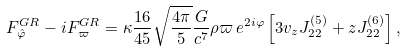<formula> <loc_0><loc_0><loc_500><loc_500>F ^ { G R } _ { \hat { \varphi } } - i F ^ { G R } _ { \varpi } = \kappa \frac { 1 6 } { 4 5 } \sqrt { \frac { 4 \pi } { 5 } } \frac { G } { c ^ { 7 } } \rho \varpi \, e ^ { 2 i \varphi } \left [ 3 v _ { z } J ^ { ( 5 ) } _ { 2 2 } + z J ^ { ( 6 ) } _ { 2 2 } \right ] ,</formula> 